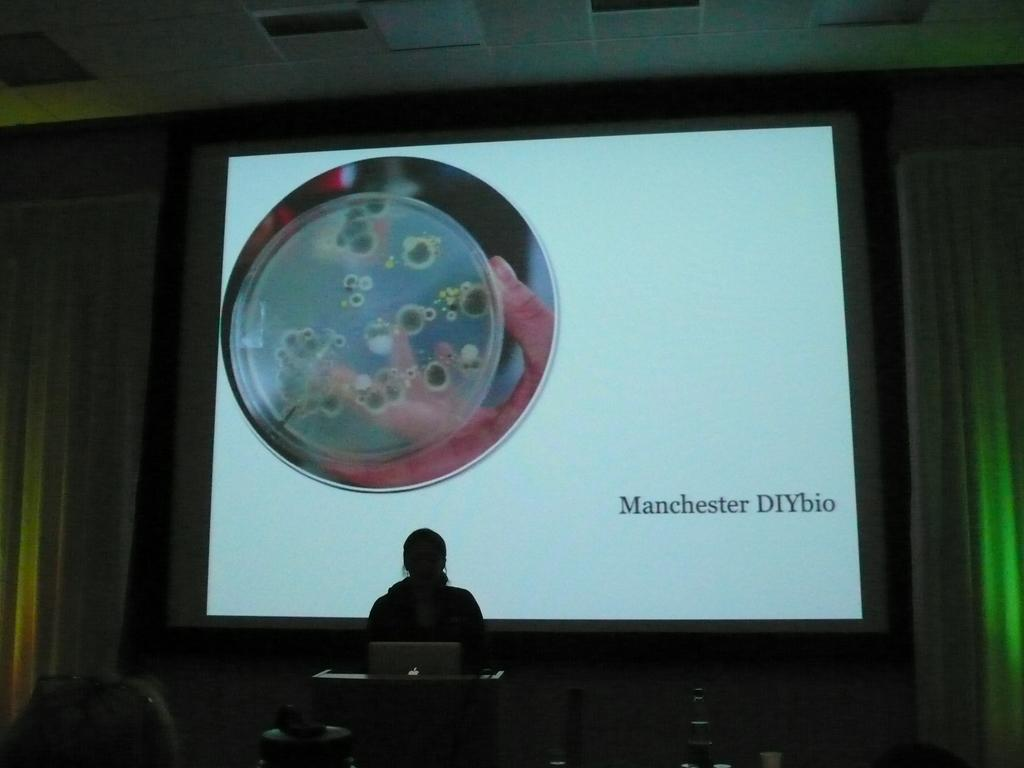<image>
Offer a succinct explanation of the picture presented. A projector screen behind a man that says Manchester DIYbio on the bottom right. 